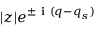Convert formula to latex. <formula><loc_0><loc_0><loc_500><loc_500>| z | e ^ { \pm i ( q - q _ { s } ) }</formula> 